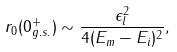Convert formula to latex. <formula><loc_0><loc_0><loc_500><loc_500>r _ { 0 } ( 0 ^ { + } _ { g . s . } ) \sim \frac { \epsilon _ { l } ^ { 2 } } { 4 ( E _ { m } - E _ { i } ) ^ { 2 } } ,</formula> 